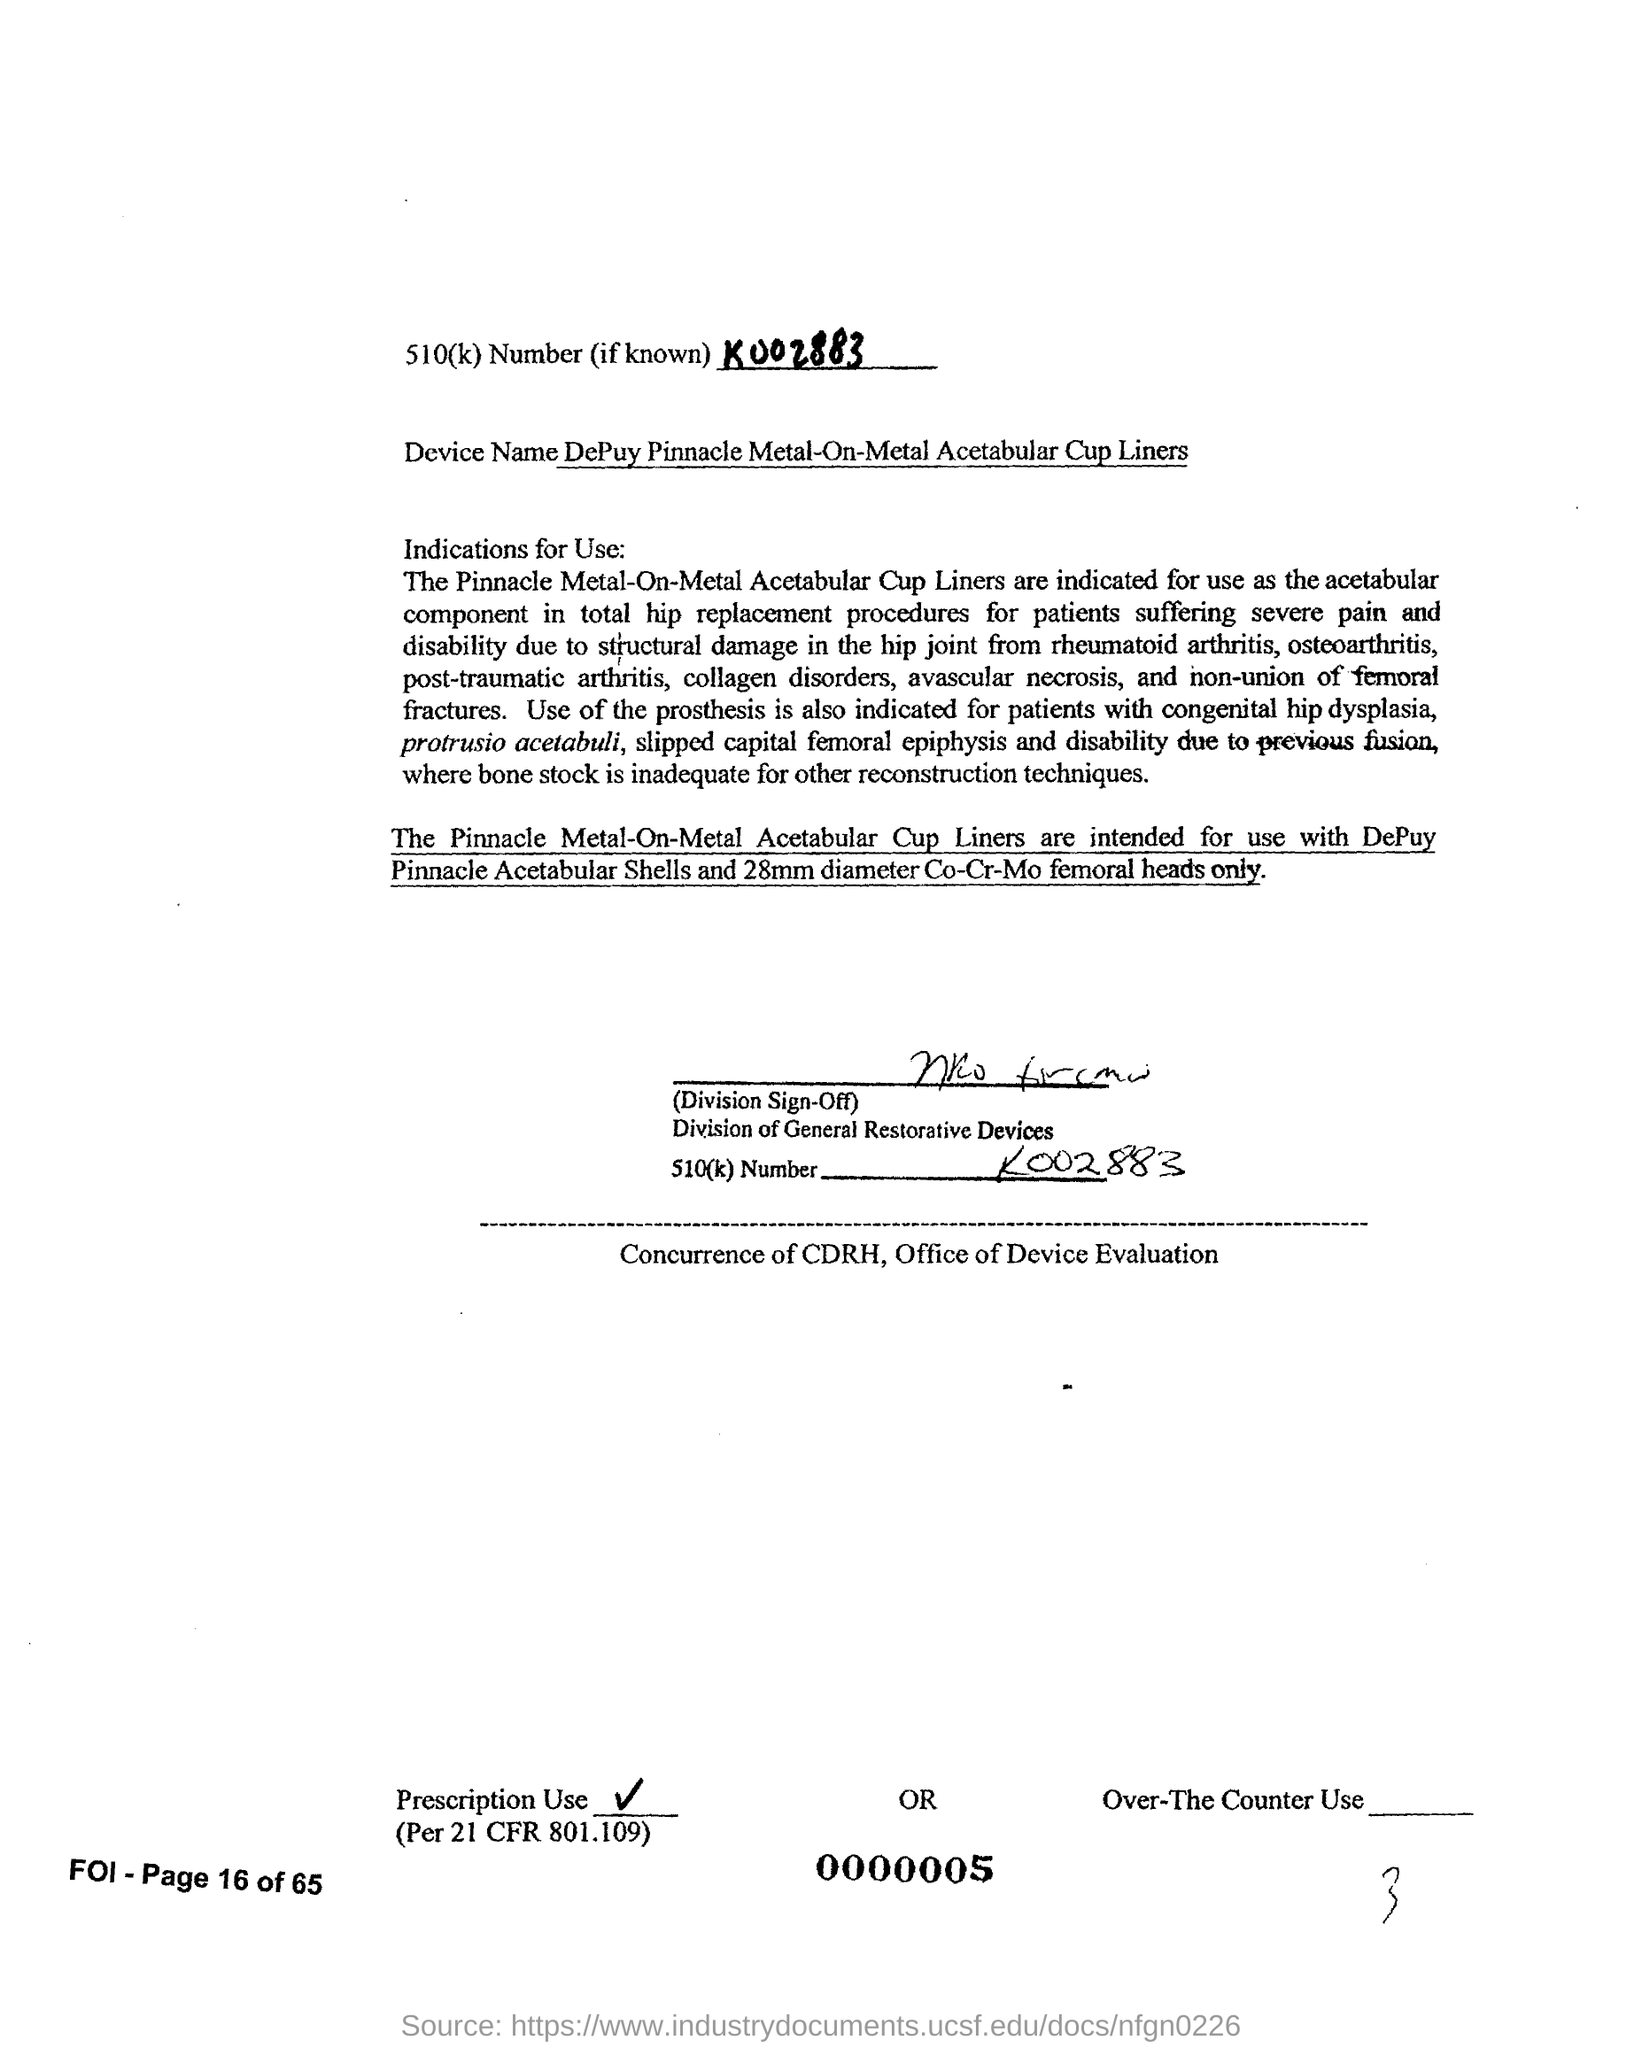What is the 510(k) Number?
Your answer should be compact. K002883. What is the device name?
Offer a very short reply. DePuy Pinnacle Metal-on-Metal Acetabular Cup Liners. 